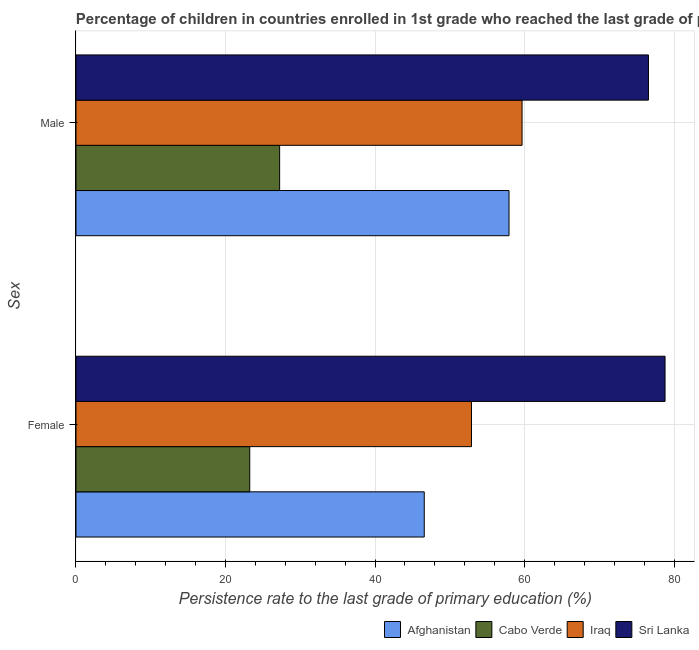How many different coloured bars are there?
Keep it short and to the point. 4. Are the number of bars on each tick of the Y-axis equal?
Offer a terse response. Yes. What is the label of the 1st group of bars from the top?
Give a very brief answer. Male. What is the persistence rate of female students in Sri Lanka?
Provide a short and direct response. 78.79. Across all countries, what is the maximum persistence rate of male students?
Offer a very short reply. 76.57. Across all countries, what is the minimum persistence rate of female students?
Offer a terse response. 23.24. In which country was the persistence rate of female students maximum?
Give a very brief answer. Sri Lanka. In which country was the persistence rate of male students minimum?
Offer a very short reply. Cabo Verde. What is the total persistence rate of male students in the graph?
Offer a terse response. 221.41. What is the difference between the persistence rate of female students in Afghanistan and that in Iraq?
Provide a succinct answer. -6.32. What is the difference between the persistence rate of male students in Iraq and the persistence rate of female students in Afghanistan?
Your response must be concise. 13.09. What is the average persistence rate of male students per country?
Keep it short and to the point. 55.35. What is the difference between the persistence rate of female students and persistence rate of male students in Iraq?
Your response must be concise. -6.77. In how many countries, is the persistence rate of male students greater than 32 %?
Ensure brevity in your answer.  3. What is the ratio of the persistence rate of male students in Sri Lanka to that in Iraq?
Offer a very short reply. 1.28. Is the persistence rate of male students in Afghanistan less than that in Cabo Verde?
Make the answer very short. No. What does the 3rd bar from the top in Male represents?
Your answer should be compact. Cabo Verde. What does the 3rd bar from the bottom in Female represents?
Ensure brevity in your answer.  Iraq. How many bars are there?
Make the answer very short. 8. What is the difference between two consecutive major ticks on the X-axis?
Your answer should be very brief. 20. Where does the legend appear in the graph?
Provide a succinct answer. Bottom right. What is the title of the graph?
Offer a terse response. Percentage of children in countries enrolled in 1st grade who reached the last grade of primary education. Does "United States" appear as one of the legend labels in the graph?
Make the answer very short. No. What is the label or title of the X-axis?
Offer a terse response. Persistence rate to the last grade of primary education (%). What is the label or title of the Y-axis?
Ensure brevity in your answer.  Sex. What is the Persistence rate to the last grade of primary education (%) of Afghanistan in Female?
Your response must be concise. 46.58. What is the Persistence rate to the last grade of primary education (%) in Cabo Verde in Female?
Your response must be concise. 23.24. What is the Persistence rate to the last grade of primary education (%) in Iraq in Female?
Provide a short and direct response. 52.9. What is the Persistence rate to the last grade of primary education (%) in Sri Lanka in Female?
Give a very brief answer. 78.79. What is the Persistence rate to the last grade of primary education (%) of Afghanistan in Male?
Offer a very short reply. 57.92. What is the Persistence rate to the last grade of primary education (%) in Cabo Verde in Male?
Offer a terse response. 27.24. What is the Persistence rate to the last grade of primary education (%) of Iraq in Male?
Keep it short and to the point. 59.67. What is the Persistence rate to the last grade of primary education (%) in Sri Lanka in Male?
Offer a very short reply. 76.57. Across all Sex, what is the maximum Persistence rate to the last grade of primary education (%) in Afghanistan?
Provide a short and direct response. 57.92. Across all Sex, what is the maximum Persistence rate to the last grade of primary education (%) in Cabo Verde?
Make the answer very short. 27.24. Across all Sex, what is the maximum Persistence rate to the last grade of primary education (%) in Iraq?
Give a very brief answer. 59.67. Across all Sex, what is the maximum Persistence rate to the last grade of primary education (%) of Sri Lanka?
Offer a terse response. 78.79. Across all Sex, what is the minimum Persistence rate to the last grade of primary education (%) in Afghanistan?
Provide a succinct answer. 46.58. Across all Sex, what is the minimum Persistence rate to the last grade of primary education (%) in Cabo Verde?
Your answer should be very brief. 23.24. Across all Sex, what is the minimum Persistence rate to the last grade of primary education (%) of Iraq?
Offer a terse response. 52.9. Across all Sex, what is the minimum Persistence rate to the last grade of primary education (%) of Sri Lanka?
Offer a terse response. 76.57. What is the total Persistence rate to the last grade of primary education (%) in Afghanistan in the graph?
Ensure brevity in your answer.  104.51. What is the total Persistence rate to the last grade of primary education (%) of Cabo Verde in the graph?
Keep it short and to the point. 50.48. What is the total Persistence rate to the last grade of primary education (%) in Iraq in the graph?
Your response must be concise. 112.57. What is the total Persistence rate to the last grade of primary education (%) in Sri Lanka in the graph?
Provide a short and direct response. 155.37. What is the difference between the Persistence rate to the last grade of primary education (%) of Afghanistan in Female and that in Male?
Provide a succinct answer. -11.34. What is the difference between the Persistence rate to the last grade of primary education (%) of Cabo Verde in Female and that in Male?
Your answer should be very brief. -4. What is the difference between the Persistence rate to the last grade of primary education (%) of Iraq in Female and that in Male?
Offer a very short reply. -6.77. What is the difference between the Persistence rate to the last grade of primary education (%) in Sri Lanka in Female and that in Male?
Provide a short and direct response. 2.22. What is the difference between the Persistence rate to the last grade of primary education (%) in Afghanistan in Female and the Persistence rate to the last grade of primary education (%) in Cabo Verde in Male?
Give a very brief answer. 19.34. What is the difference between the Persistence rate to the last grade of primary education (%) of Afghanistan in Female and the Persistence rate to the last grade of primary education (%) of Iraq in Male?
Offer a very short reply. -13.09. What is the difference between the Persistence rate to the last grade of primary education (%) of Afghanistan in Female and the Persistence rate to the last grade of primary education (%) of Sri Lanka in Male?
Provide a succinct answer. -29.99. What is the difference between the Persistence rate to the last grade of primary education (%) in Cabo Verde in Female and the Persistence rate to the last grade of primary education (%) in Iraq in Male?
Make the answer very short. -36.43. What is the difference between the Persistence rate to the last grade of primary education (%) of Cabo Verde in Female and the Persistence rate to the last grade of primary education (%) of Sri Lanka in Male?
Give a very brief answer. -53.33. What is the difference between the Persistence rate to the last grade of primary education (%) in Iraq in Female and the Persistence rate to the last grade of primary education (%) in Sri Lanka in Male?
Offer a terse response. -23.67. What is the average Persistence rate to the last grade of primary education (%) in Afghanistan per Sex?
Make the answer very short. 52.25. What is the average Persistence rate to the last grade of primary education (%) of Cabo Verde per Sex?
Ensure brevity in your answer.  25.24. What is the average Persistence rate to the last grade of primary education (%) of Iraq per Sex?
Offer a very short reply. 56.28. What is the average Persistence rate to the last grade of primary education (%) in Sri Lanka per Sex?
Offer a very short reply. 77.68. What is the difference between the Persistence rate to the last grade of primary education (%) in Afghanistan and Persistence rate to the last grade of primary education (%) in Cabo Verde in Female?
Offer a terse response. 23.34. What is the difference between the Persistence rate to the last grade of primary education (%) in Afghanistan and Persistence rate to the last grade of primary education (%) in Iraq in Female?
Your answer should be compact. -6.32. What is the difference between the Persistence rate to the last grade of primary education (%) in Afghanistan and Persistence rate to the last grade of primary education (%) in Sri Lanka in Female?
Offer a very short reply. -32.21. What is the difference between the Persistence rate to the last grade of primary education (%) of Cabo Verde and Persistence rate to the last grade of primary education (%) of Iraq in Female?
Provide a succinct answer. -29.66. What is the difference between the Persistence rate to the last grade of primary education (%) in Cabo Verde and Persistence rate to the last grade of primary education (%) in Sri Lanka in Female?
Your answer should be compact. -55.55. What is the difference between the Persistence rate to the last grade of primary education (%) of Iraq and Persistence rate to the last grade of primary education (%) of Sri Lanka in Female?
Offer a very short reply. -25.89. What is the difference between the Persistence rate to the last grade of primary education (%) of Afghanistan and Persistence rate to the last grade of primary education (%) of Cabo Verde in Male?
Your response must be concise. 30.68. What is the difference between the Persistence rate to the last grade of primary education (%) in Afghanistan and Persistence rate to the last grade of primary education (%) in Iraq in Male?
Give a very brief answer. -1.75. What is the difference between the Persistence rate to the last grade of primary education (%) in Afghanistan and Persistence rate to the last grade of primary education (%) in Sri Lanka in Male?
Your answer should be very brief. -18.65. What is the difference between the Persistence rate to the last grade of primary education (%) in Cabo Verde and Persistence rate to the last grade of primary education (%) in Iraq in Male?
Provide a succinct answer. -32.43. What is the difference between the Persistence rate to the last grade of primary education (%) in Cabo Verde and Persistence rate to the last grade of primary education (%) in Sri Lanka in Male?
Offer a terse response. -49.33. What is the difference between the Persistence rate to the last grade of primary education (%) in Iraq and Persistence rate to the last grade of primary education (%) in Sri Lanka in Male?
Ensure brevity in your answer.  -16.91. What is the ratio of the Persistence rate to the last grade of primary education (%) in Afghanistan in Female to that in Male?
Your answer should be very brief. 0.8. What is the ratio of the Persistence rate to the last grade of primary education (%) in Cabo Verde in Female to that in Male?
Your answer should be compact. 0.85. What is the ratio of the Persistence rate to the last grade of primary education (%) of Iraq in Female to that in Male?
Ensure brevity in your answer.  0.89. What is the ratio of the Persistence rate to the last grade of primary education (%) of Sri Lanka in Female to that in Male?
Your answer should be very brief. 1.03. What is the difference between the highest and the second highest Persistence rate to the last grade of primary education (%) of Afghanistan?
Your answer should be very brief. 11.34. What is the difference between the highest and the second highest Persistence rate to the last grade of primary education (%) in Cabo Verde?
Provide a short and direct response. 4. What is the difference between the highest and the second highest Persistence rate to the last grade of primary education (%) in Iraq?
Give a very brief answer. 6.77. What is the difference between the highest and the second highest Persistence rate to the last grade of primary education (%) of Sri Lanka?
Keep it short and to the point. 2.22. What is the difference between the highest and the lowest Persistence rate to the last grade of primary education (%) in Afghanistan?
Your answer should be very brief. 11.34. What is the difference between the highest and the lowest Persistence rate to the last grade of primary education (%) in Cabo Verde?
Offer a very short reply. 4. What is the difference between the highest and the lowest Persistence rate to the last grade of primary education (%) of Iraq?
Provide a short and direct response. 6.77. What is the difference between the highest and the lowest Persistence rate to the last grade of primary education (%) of Sri Lanka?
Keep it short and to the point. 2.22. 